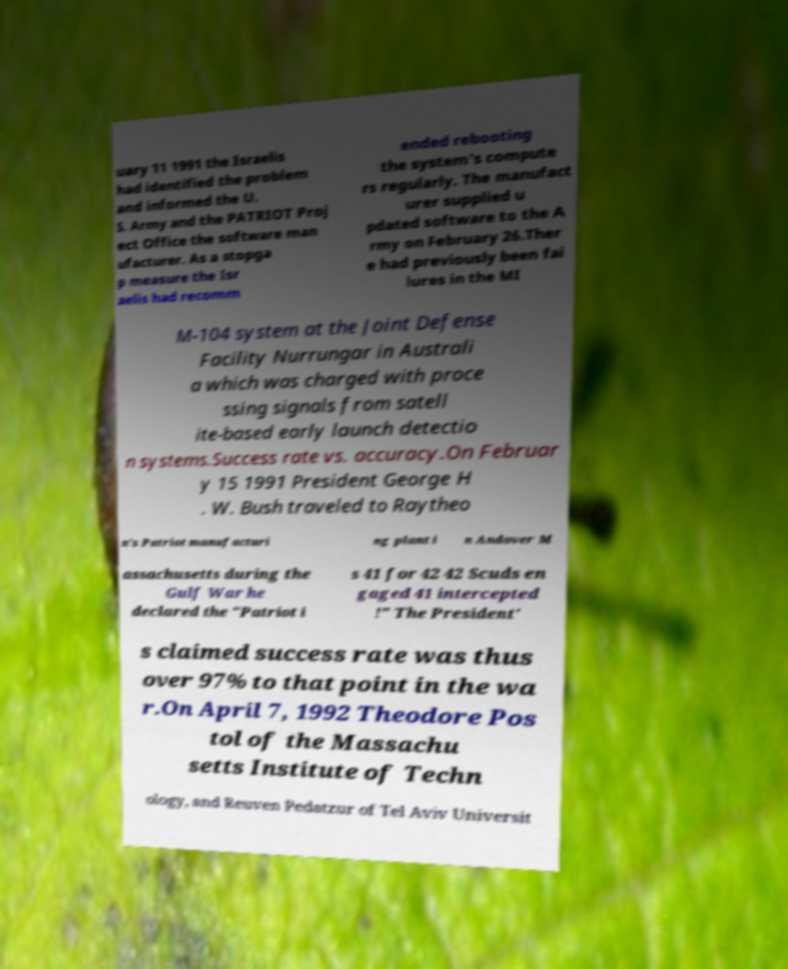Please identify and transcribe the text found in this image. uary 11 1991 the Israelis had identified the problem and informed the U. S. Army and the PATRIOT Proj ect Office the software man ufacturer. As a stopga p measure the Isr aelis had recomm ended rebooting the system's compute rs regularly. The manufact urer supplied u pdated software to the A rmy on February 26.Ther e had previously been fai lures in the MI M-104 system at the Joint Defense Facility Nurrungar in Australi a which was charged with proce ssing signals from satell ite-based early launch detectio n systems.Success rate vs. accuracy.On Februar y 15 1991 President George H . W. Bush traveled to Raytheo n's Patriot manufacturi ng plant i n Andover M assachusetts during the Gulf War he declared the "Patriot i s 41 for 42 42 Scuds en gaged 41 intercepted !" The President' s claimed success rate was thus over 97% to that point in the wa r.On April 7, 1992 Theodore Pos tol of the Massachu setts Institute of Techn ology, and Reuven Pedatzur of Tel Aviv Universit 